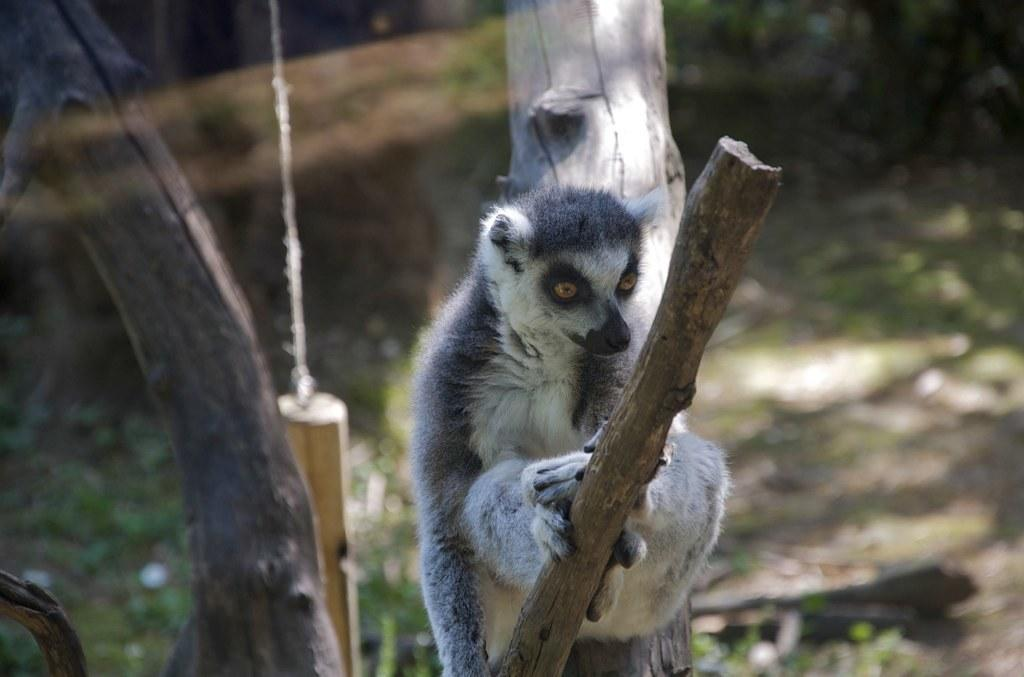What is the animal doing in the image? The animal is sitting on a tree in the image. What can be seen in the background of the image? There are plants and grass visible in the backdrop of the image. What type of can is visible in the image? There is no can present in the image; it features an animal sitting on a tree with plants and grass in the backdrop. 